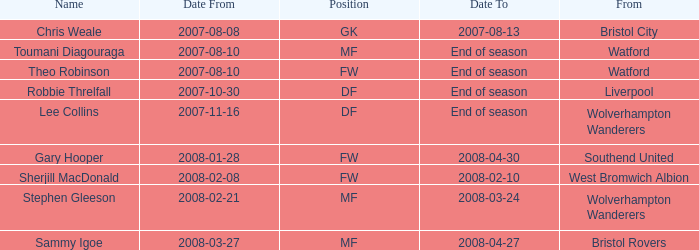What was the from for the Date From of 2007-08-08? Bristol City. 